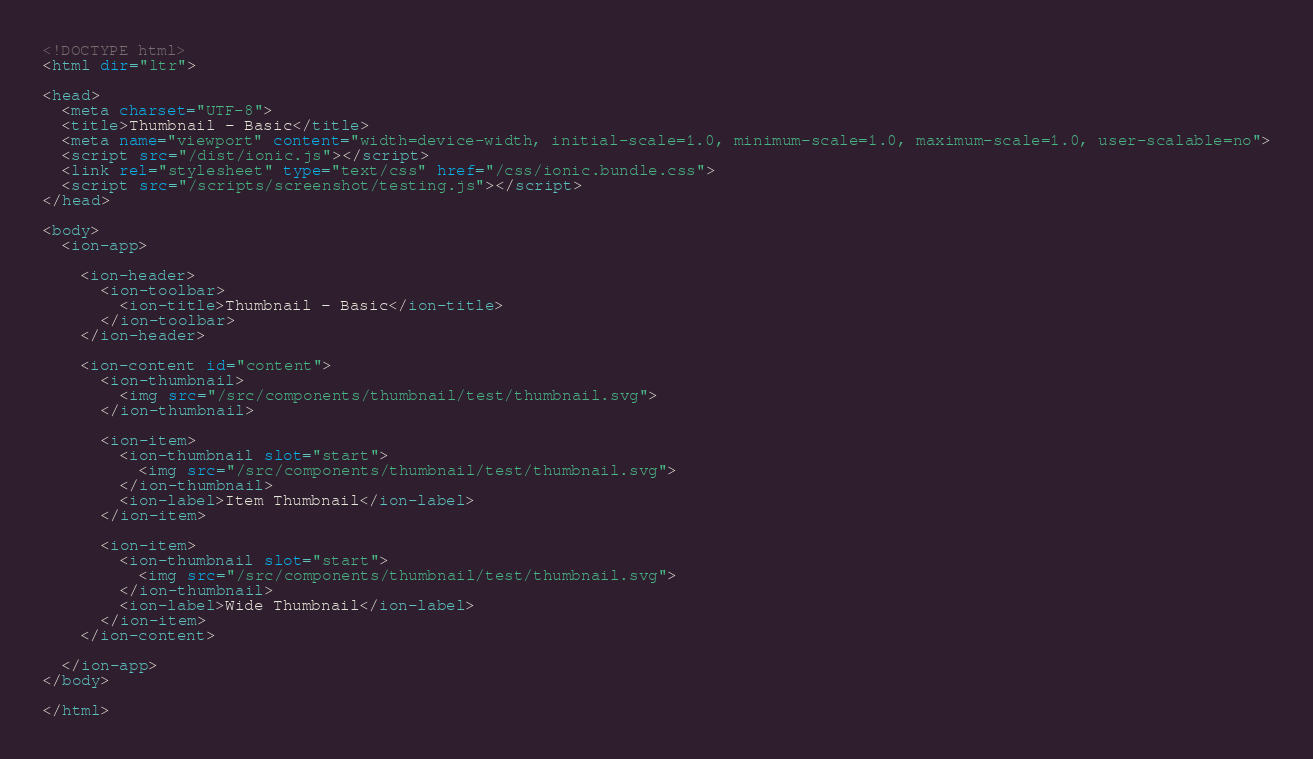<code> <loc_0><loc_0><loc_500><loc_500><_HTML_><!DOCTYPE html>
<html dir="ltr">

<head>
  <meta charset="UTF-8">
  <title>Thumbnail - Basic</title>
  <meta name="viewport" content="width=device-width, initial-scale=1.0, minimum-scale=1.0, maximum-scale=1.0, user-scalable=no">
  <script src="/dist/ionic.js"></script>
  <link rel="stylesheet" type="text/css" href="/css/ionic.bundle.css">
  <script src="/scripts/screenshot/testing.js"></script>
</head>

<body>
  <ion-app>

    <ion-header>
      <ion-toolbar>
        <ion-title>Thumbnail - Basic</ion-title>
      </ion-toolbar>
    </ion-header>

    <ion-content id="content">
      <ion-thumbnail>
        <img src="/src/components/thumbnail/test/thumbnail.svg">
      </ion-thumbnail>

      <ion-item>
        <ion-thumbnail slot="start">
          <img src="/src/components/thumbnail/test/thumbnail.svg">
        </ion-thumbnail>
        <ion-label>Item Thumbnail</ion-label>
      </ion-item>

      <ion-item>
        <ion-thumbnail slot="start">
          <img src="/src/components/thumbnail/test/thumbnail.svg">
        </ion-thumbnail>
        <ion-label>Wide Thumbnail</ion-label>
      </ion-item>
    </ion-content>

  </ion-app>
</body>

</html>
</code> 